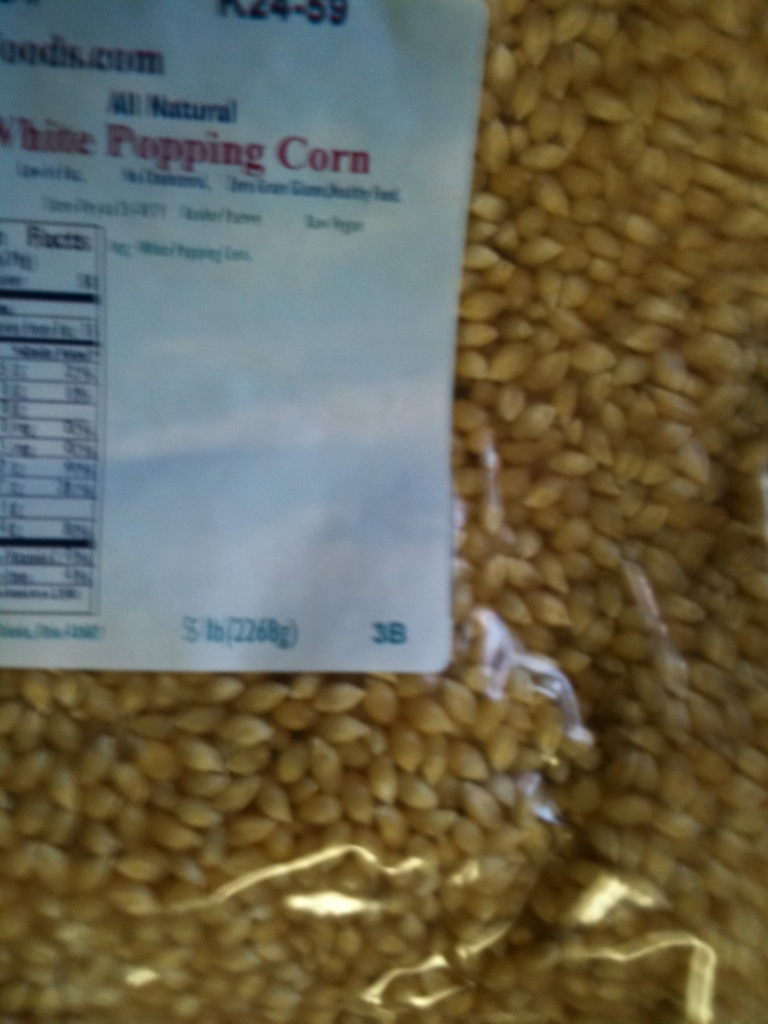What is this item? This is a package of all-natural white popping corn. It's typically used for making homemade popcorn by heating the kernels, which causes them to pop and expand into the fluffy snack we all love. 